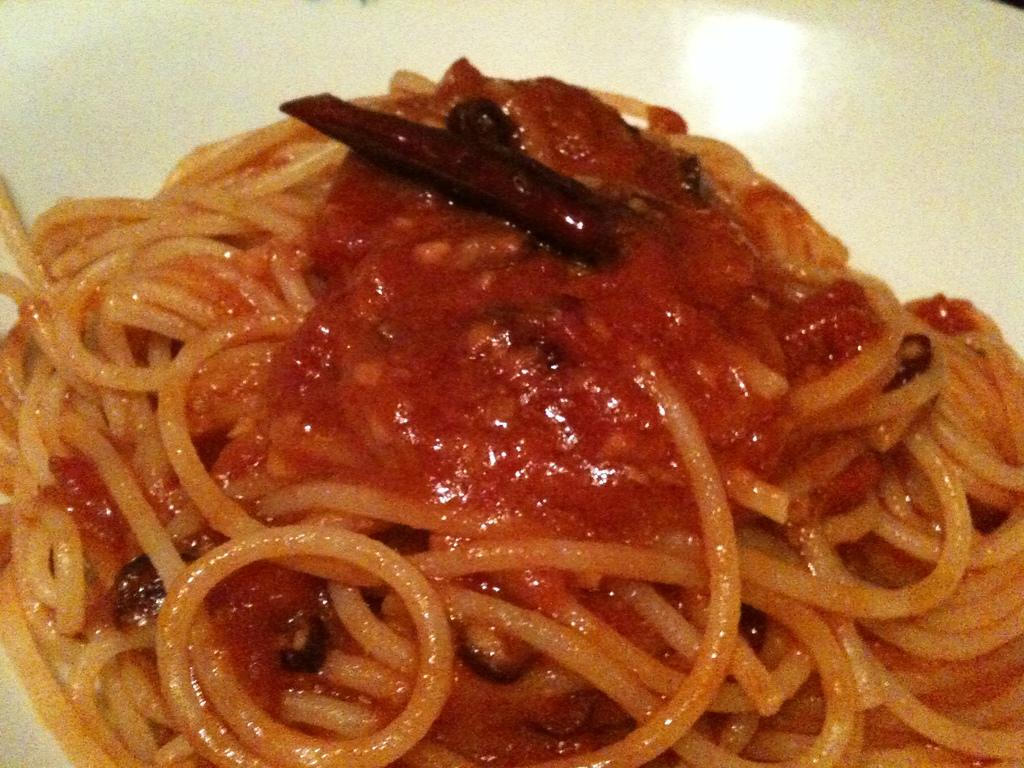What type of food is on the plate in the image? There are noodles on a plate in the image. What is covering the noodles on the plate? The noodles are topped with sauce. Where is the grandmother sitting with her dolls in the image? There is no grandmother or dolls present in the image; it only features a plate of noodles topped with sauce. 